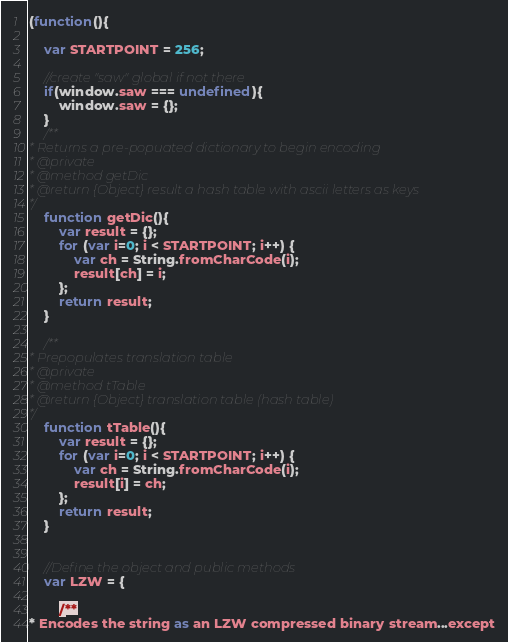Convert code to text. <code><loc_0><loc_0><loc_500><loc_500><_JavaScript_>(function(){
    
    var STARTPOINT = 256;
    
    //create "saw" global if not there
    if(window.saw === undefined){
        window.saw = {};
    }
    /**
* Returns a pre-popuated dictionary to begin encoding
* @private
* @method getDic
* @return {Object} result a hash table with ascii letters as keys
*/
    function getDic(){
        var result = {};
        for (var i=0; i < STARTPOINT; i++) {
            var ch = String.fromCharCode(i);
            result[ch] = i;
        };
        return result;
    }
    
    /**
* Prepopulates translation table
* @private
* @method tTable
* @return {Object} translation table (hash table)
*/
    function tTable(){
        var result = {};
        for (var i=0; i < STARTPOINT; i++) {
            var ch = String.fromCharCode(i);
            result[i] = ch;
        };
        return result;
    }
    
    
    //Define the object and public methods
    var LZW = {
        
        /**
* Encodes the string as an LZW compressed binary stream...except</code> 